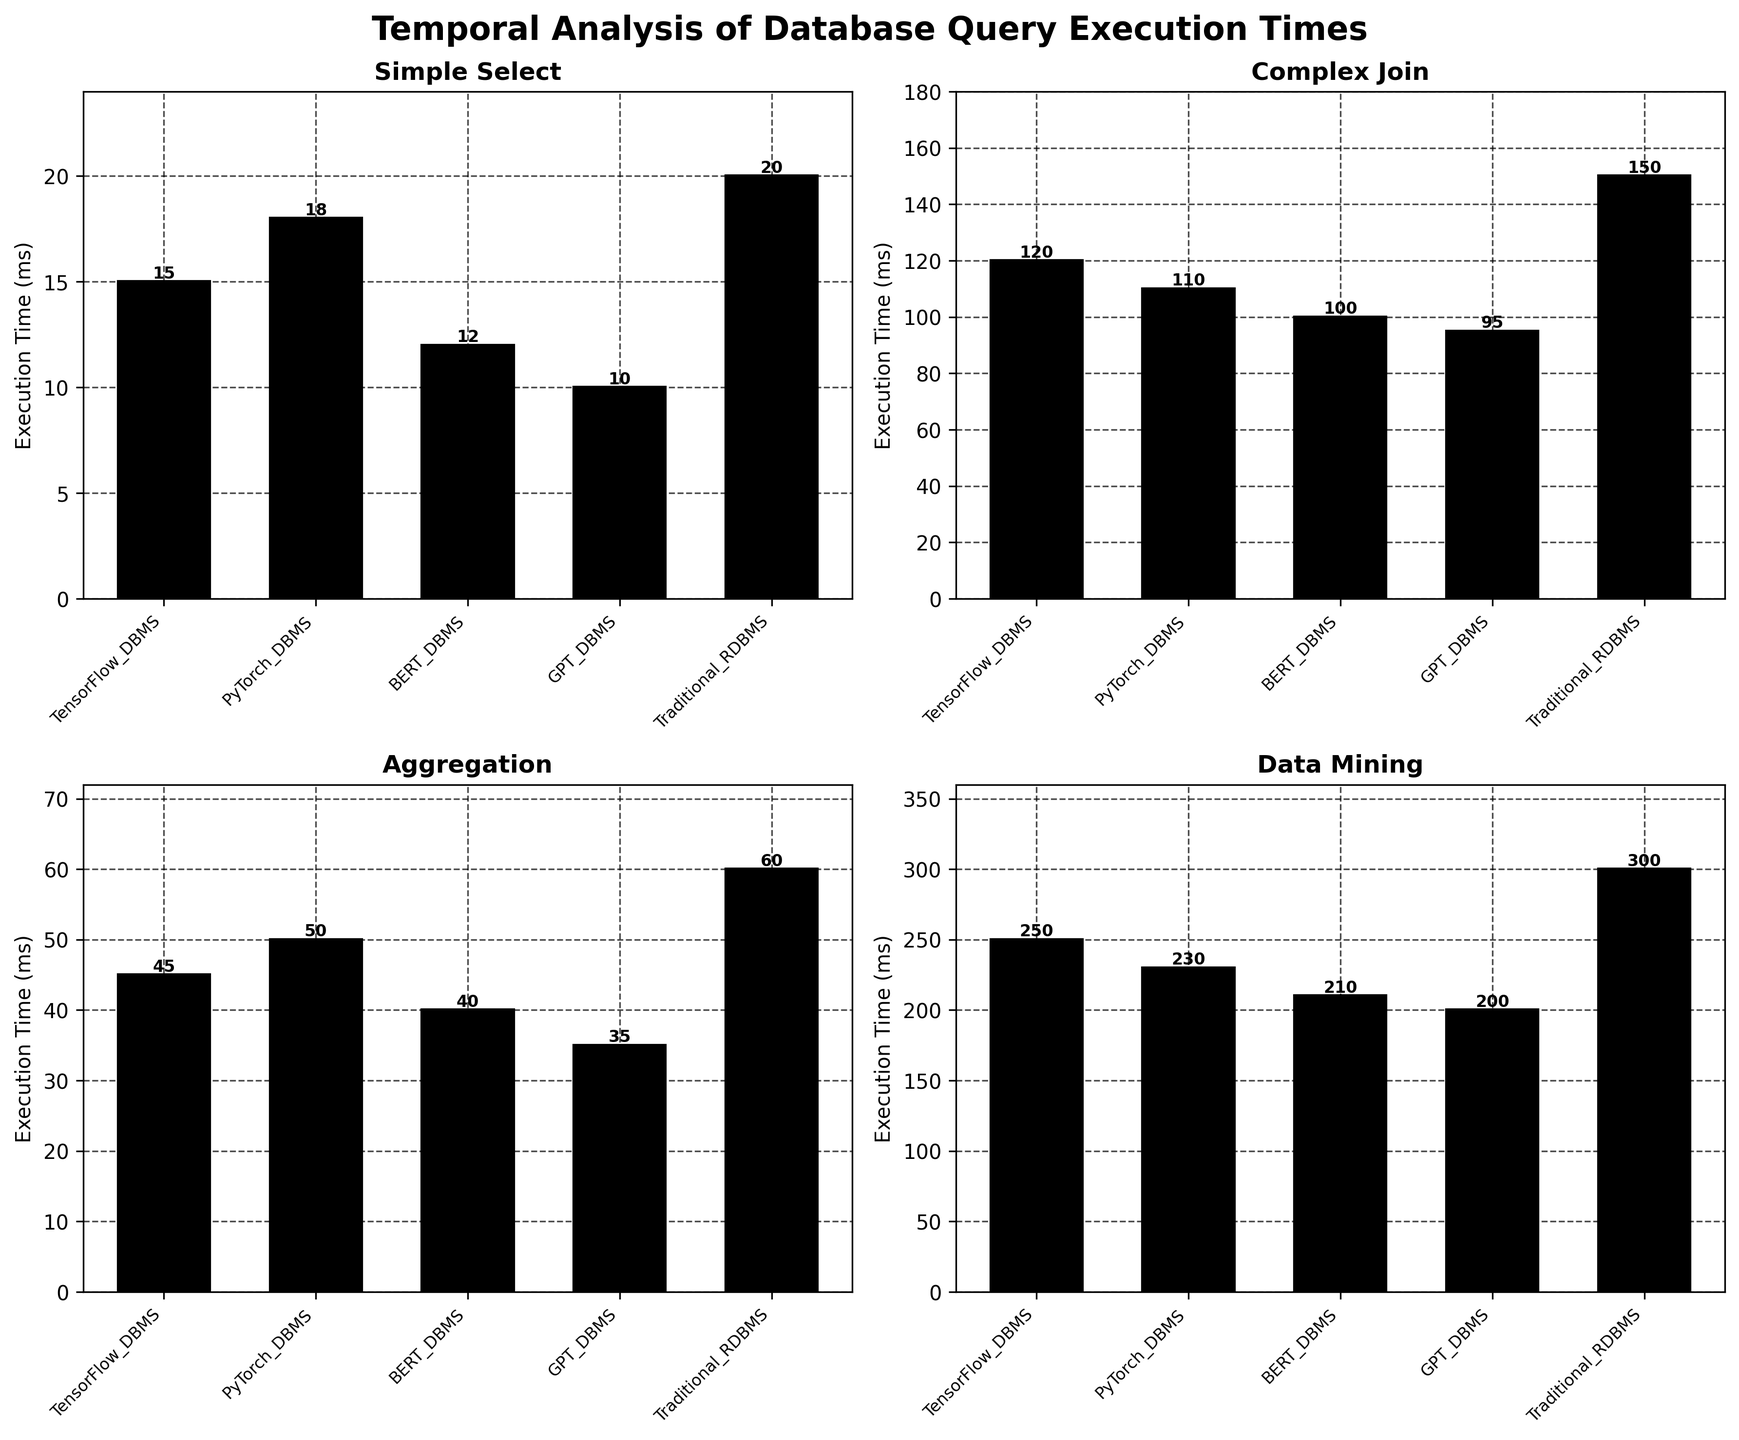What's the title of the figure? The title is located at the top of the figure, usually written in larger and bold font to give an overview of what the figure is about.
Answer: Temporal Analysis of Database Query Execution Times Which system has the lowest execution time for the 'Complex Join' query? By observing the subplot titled 'Complex Join' and comparing the bar heights for each system, we can see which one is the shortest.
Answer: GPT_DBMS What is the total execution time for the 'Simple Select' query, across all systems? Find the execution times for the 'Simple Select' query for each system from the corresponding subplot and add them together (TensorFlow_DBMS: 15 ms, PyTorch_DBMS: 18 ms, BERT_DBMS: 12 ms, GPT_DBMS: 10 ms, Traditional_RDBMS: 20 ms). The total is 15 + 18 + 12 + 10 + 20 = 75 ms.
Answer: 75 ms Which query type has the most significant difference in execution time between TensorFlow_DBMS and Traditional_RDBMS systems? For each query type, calculate the absolute difference in execution time between TensorFlow_DBMS and Traditional_RDBMS and compare the results. The differences are: Simple Select: 5 ms, Complex Join: 30 ms, Aggregation: 15 ms, Data Mining: 50 ms. The most significant difference is for the Data Mining query.
Answer: Data Mining For the 'Aggregation' query, rank the systems from fastest to slowest. Examine the subplot titled 'Aggregation' and order the systems based on the bar heights from shortest to tallest.
Answer: GPT_DBMS, BERT_DBMS, TensorFlow_DBMS, PyTorch_DBMS, Traditional_RDBMS What's the average execution time for the 'Data Mining' query across all systems? Sum the execution times for the 'Data Mining' query across all systems (TensorFlow_DBMS: 250 ms, PyTorch_DBMS: 230 ms, BERT_DBMS: 210 ms, GPT_DBMS: 200 ms, Traditional_RDBMS: 300 ms) and divide by the number of systems. The average is (250 + 230 + 210 + 200 + 300) / 5 = 238 ms.
Answer: 238 ms Which query type has the highest variation in execution times across different systems? For each query type, subtract the minimum execution time from the maximum. The variations are: Simple Select: 10 ms (20 - 10), Complex Join: 55 ms (150 - 95), Aggregation: 25 ms (60 - 35), Data Mining: 100 ms (300 - 200). The highest variation is for the Data Mining query.
Answer: Data Mining Between PyTorch_DBMS and BERT_DBMS, which one is generally more efficient across all queries? For each query, compare the execution times of PyTorch_DBMS and BERT_DBMS: 
Simple Select: PyTorch_DBMS - 18 ms, BERT_DBMS - 12 ms 
Complex Join: PyTorch_DBMS - 110 ms, BERT_DBMS - 100 ms 
Aggregation: PyTorch_DBMS - 50 ms, BERT_DBMS - 40 ms 
Data Mining: PyTorch_DBMS - 230 ms, BERT_DBMS - 210 ms 
BERT_DBMS is more efficient for all query types.
Answer: BERT_DBMS How many subplots are present in the figure? The figure shows four different query types, each represented by a subplot, arranged in a 2x2 grid.
Answer: 4 